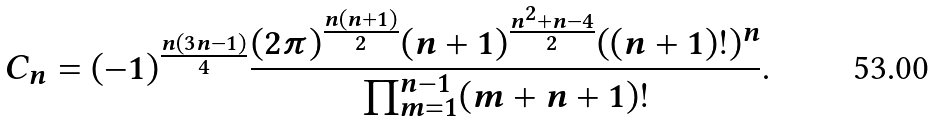Convert formula to latex. <formula><loc_0><loc_0><loc_500><loc_500>C _ { n } = ( - 1 ) ^ { \frac { n ( 3 n - 1 ) } 4 } \frac { ( 2 \pi ) ^ { \frac { n ( n + 1 ) } 2 } ( n + 1 ) ^ { \frac { n ^ { 2 } + n - 4 } 2 } ( ( n + 1 ) ! ) ^ { n } } { \prod _ { m = 1 } ^ { n - 1 } ( m + n + 1 ) ! } .</formula> 